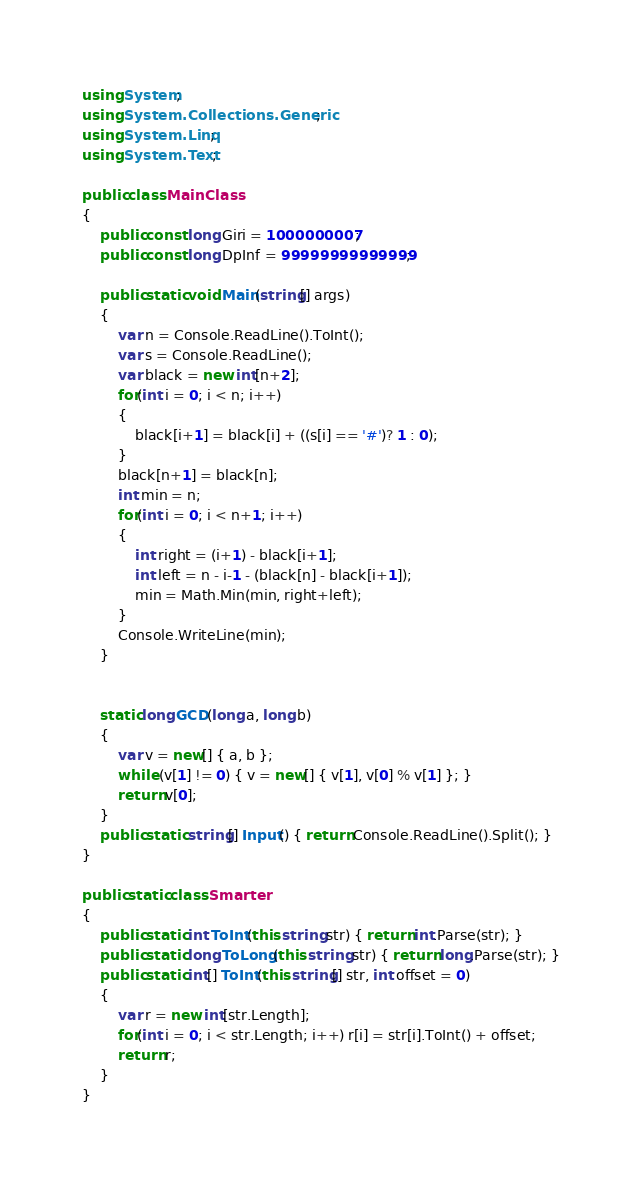<code> <loc_0><loc_0><loc_500><loc_500><_C#_>using System;
using System.Collections.Generic;
using System.Linq;
using System.Text;

public class MainClass
{
	public const long Giri = 1000000007;
	public const long DpInf = 99999999999999;
	
	public static void Main(string[] args)
	{
		var n = Console.ReadLine().ToInt();
		var s = Console.ReadLine();
		var black = new int[n+2];
		for(int i = 0; i < n; i++)
		{
			black[i+1] = black[i] + ((s[i] == '#')? 1 : 0);
		}
		black[n+1] = black[n];
		int min = n;
		for(int i = 0; i < n+1; i++)
		{
			int right = (i+1) - black[i+1];
			int left = n - i-1 - (black[n] - black[i+1]);
			min = Math.Min(min, right+left);
		}
		Console.WriteLine(min);
	}
	
	
	static long GCD(long a, long b)
	{
		var v = new[] { a, b };
		while (v[1] != 0) { v = new[] { v[1], v[0] % v[1] }; }
		return v[0];
	}
	public static string[] Input() { return Console.ReadLine().Split(); }
}

public static class Smarter
{
	public static int ToInt(this string str) { return int.Parse(str); }
	public static long ToLong(this string str) { return long.Parse(str); }
	public static int[] ToInt(this string[] str, int offset = 0)
	{
		var r = new int[str.Length];
		for(int i = 0; i < str.Length; i++) r[i] = str[i].ToInt() + offset;
		return r;
	}
}</code> 